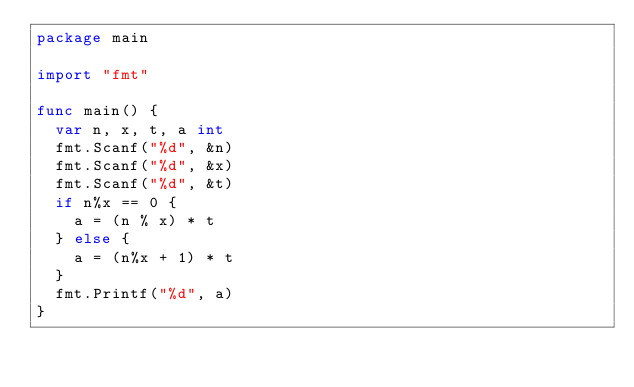Convert code to text. <code><loc_0><loc_0><loc_500><loc_500><_Go_>package main

import "fmt"

func main() {
	var n, x, t, a int
	fmt.Scanf("%d", &n)
	fmt.Scanf("%d", &x)
	fmt.Scanf("%d", &t)
	if n%x == 0 {
		a = (n % x) * t
	} else {
		a = (n%x + 1) * t
	}
	fmt.Printf("%d", a)
}
</code> 